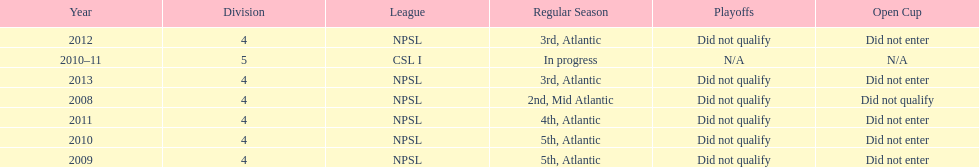How did they place the year after they were 4th in the regular season? 3rd. 